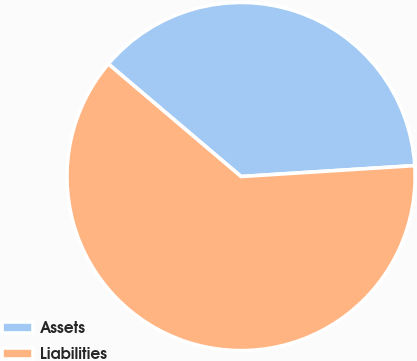Convert chart. <chart><loc_0><loc_0><loc_500><loc_500><pie_chart><fcel>Assets<fcel>Liabilities<nl><fcel>37.8%<fcel>62.2%<nl></chart> 